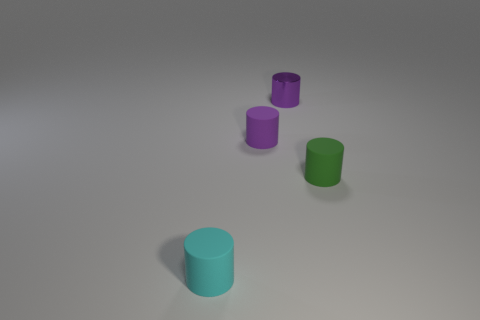What is the material of the small green thing that is the same shape as the small cyan rubber thing?
Give a very brief answer. Rubber. There is a thing that is left of the small purple matte thing; is it the same color as the small shiny cylinder?
Your answer should be compact. No. How many metal things are tiny cylinders or blue spheres?
Make the answer very short. 1. There is a small green matte object; what shape is it?
Offer a very short reply. Cylinder. Is the cyan object made of the same material as the small green cylinder?
Provide a succinct answer. Yes. There is a cyan rubber object left of the purple cylinder in front of the small metallic object; are there any purple shiny cylinders behind it?
Keep it short and to the point. Yes. What number of other things are there of the same shape as the small cyan matte object?
Provide a short and direct response. 3. There is a small rubber cylinder that is right of the small metallic object that is behind the rubber object that is behind the green object; what is its color?
Your answer should be very brief. Green. Are there more small rubber cylinders that are in front of the small green matte thing than small purple metal objects left of the small cyan object?
Give a very brief answer. Yes. How many other objects are there of the same size as the shiny cylinder?
Offer a very short reply. 3. 